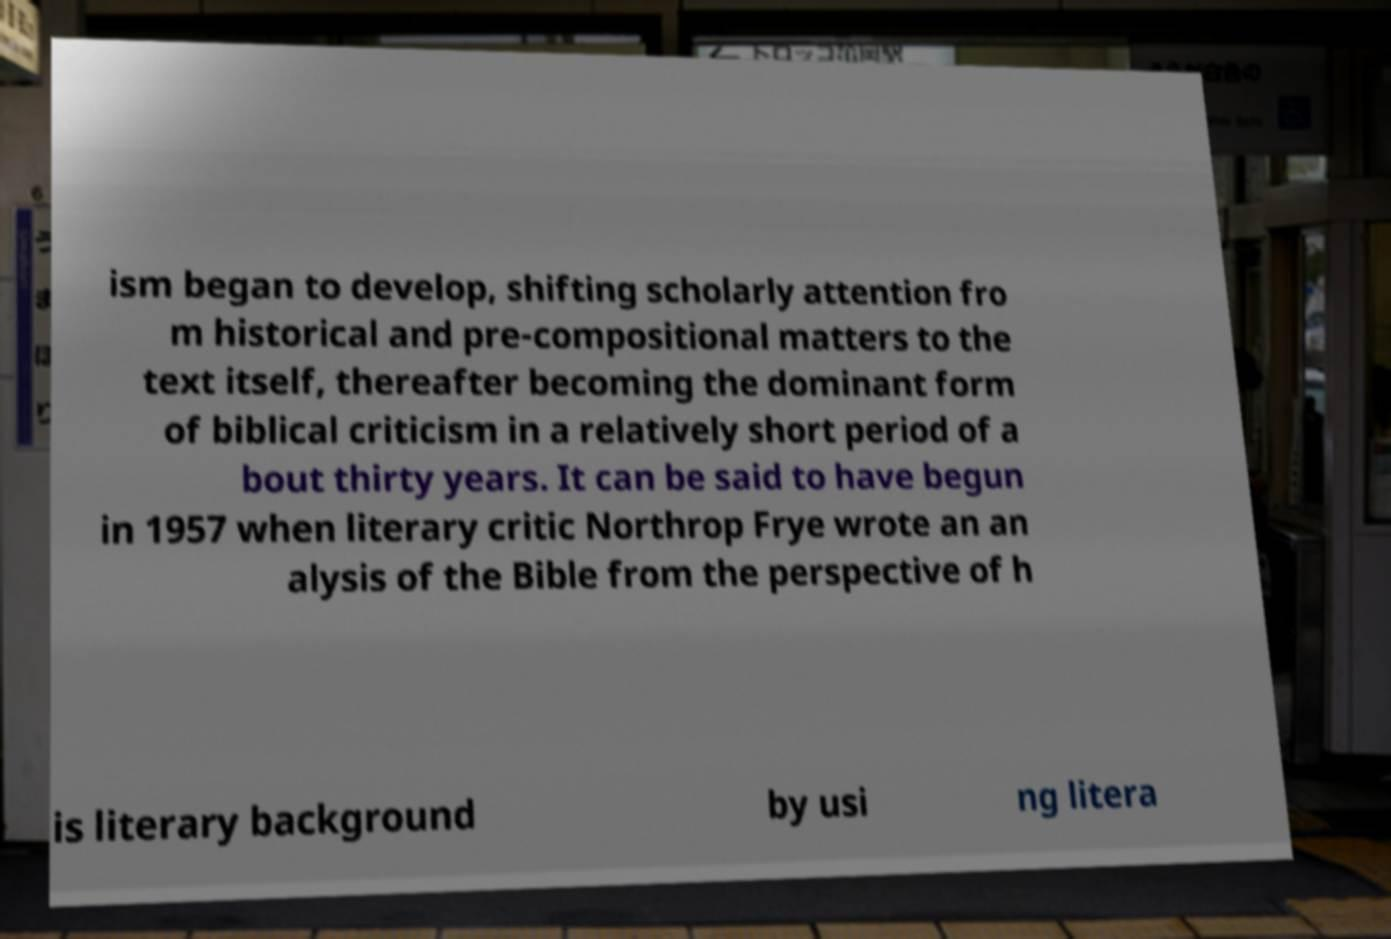Can you accurately transcribe the text from the provided image for me? ism began to develop, shifting scholarly attention fro m historical and pre-compositional matters to the text itself, thereafter becoming the dominant form of biblical criticism in a relatively short period of a bout thirty years. It can be said to have begun in 1957 when literary critic Northrop Frye wrote an an alysis of the Bible from the perspective of h is literary background by usi ng litera 